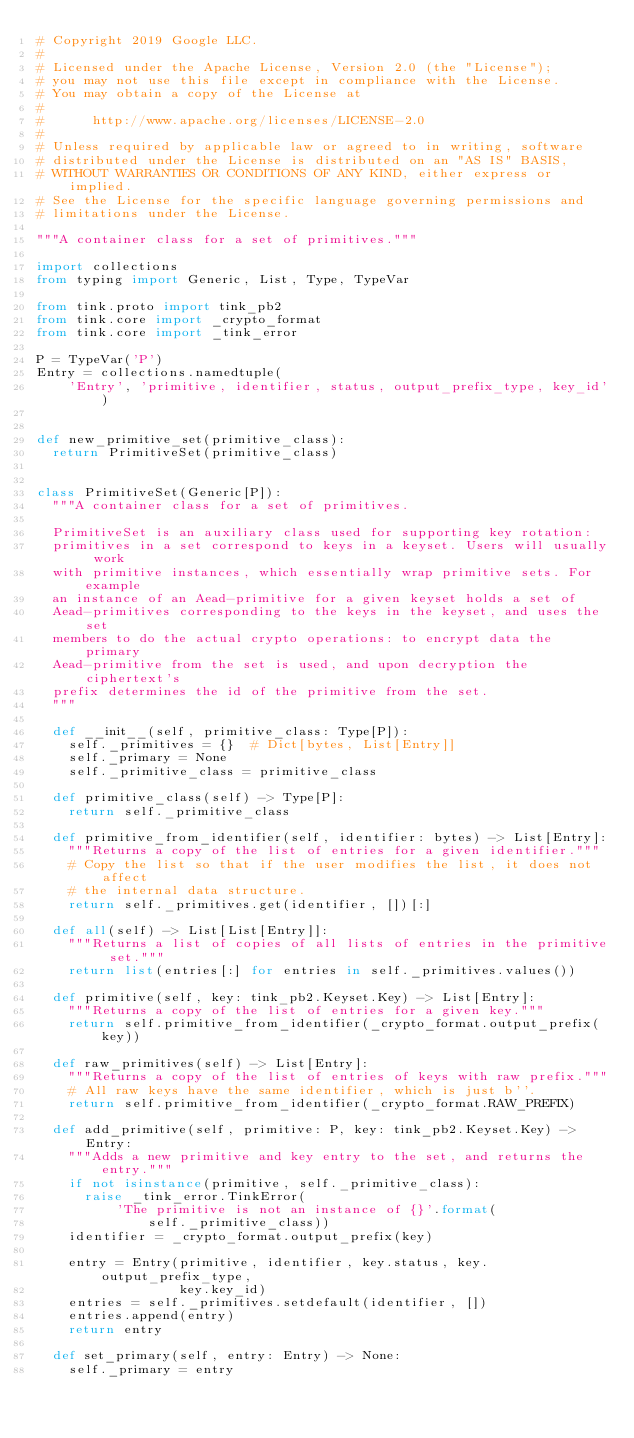<code> <loc_0><loc_0><loc_500><loc_500><_Python_># Copyright 2019 Google LLC.
#
# Licensed under the Apache License, Version 2.0 (the "License");
# you may not use this file except in compliance with the License.
# You may obtain a copy of the License at
#
#      http://www.apache.org/licenses/LICENSE-2.0
#
# Unless required by applicable law or agreed to in writing, software
# distributed under the License is distributed on an "AS IS" BASIS,
# WITHOUT WARRANTIES OR CONDITIONS OF ANY KIND, either express or implied.
# See the License for the specific language governing permissions and
# limitations under the License.

"""A container class for a set of primitives."""

import collections
from typing import Generic, List, Type, TypeVar

from tink.proto import tink_pb2
from tink.core import _crypto_format
from tink.core import _tink_error

P = TypeVar('P')
Entry = collections.namedtuple(
    'Entry', 'primitive, identifier, status, output_prefix_type, key_id')


def new_primitive_set(primitive_class):
  return PrimitiveSet(primitive_class)


class PrimitiveSet(Generic[P]):
  """A container class for a set of primitives.

  PrimitiveSet is an auxiliary class used for supporting key rotation:
  primitives in a set correspond to keys in a keyset. Users will usually work
  with primitive instances, which essentially wrap primitive sets. For example
  an instance of an Aead-primitive for a given keyset holds a set of
  Aead-primitives corresponding to the keys in the keyset, and uses the set
  members to do the actual crypto operations: to encrypt data the primary
  Aead-primitive from the set is used, and upon decryption the ciphertext's
  prefix determines the id of the primitive from the set.
  """

  def __init__(self, primitive_class: Type[P]):
    self._primitives = {}  # Dict[bytes, List[Entry]]
    self._primary = None
    self._primitive_class = primitive_class

  def primitive_class(self) -> Type[P]:
    return self._primitive_class

  def primitive_from_identifier(self, identifier: bytes) -> List[Entry]:
    """Returns a copy of the list of entries for a given identifier."""
    # Copy the list so that if the user modifies the list, it does not affect
    # the internal data structure.
    return self._primitives.get(identifier, [])[:]

  def all(self) -> List[List[Entry]]:
    """Returns a list of copies of all lists of entries in the primitive set."""
    return list(entries[:] for entries in self._primitives.values())

  def primitive(self, key: tink_pb2.Keyset.Key) -> List[Entry]:
    """Returns a copy of the list of entries for a given key."""
    return self.primitive_from_identifier(_crypto_format.output_prefix(key))

  def raw_primitives(self) -> List[Entry]:
    """Returns a copy of the list of entries of keys with raw prefix."""
    # All raw keys have the same identifier, which is just b''.
    return self.primitive_from_identifier(_crypto_format.RAW_PREFIX)

  def add_primitive(self, primitive: P, key: tink_pb2.Keyset.Key) -> Entry:
    """Adds a new primitive and key entry to the set, and returns the entry."""
    if not isinstance(primitive, self._primitive_class):
      raise _tink_error.TinkError(
          'The primitive is not an instance of {}'.format(
              self._primitive_class))
    identifier = _crypto_format.output_prefix(key)

    entry = Entry(primitive, identifier, key.status, key.output_prefix_type,
                  key.key_id)
    entries = self._primitives.setdefault(identifier, [])
    entries.append(entry)
    return entry

  def set_primary(self, entry: Entry) -> None:
    self._primary = entry
</code> 